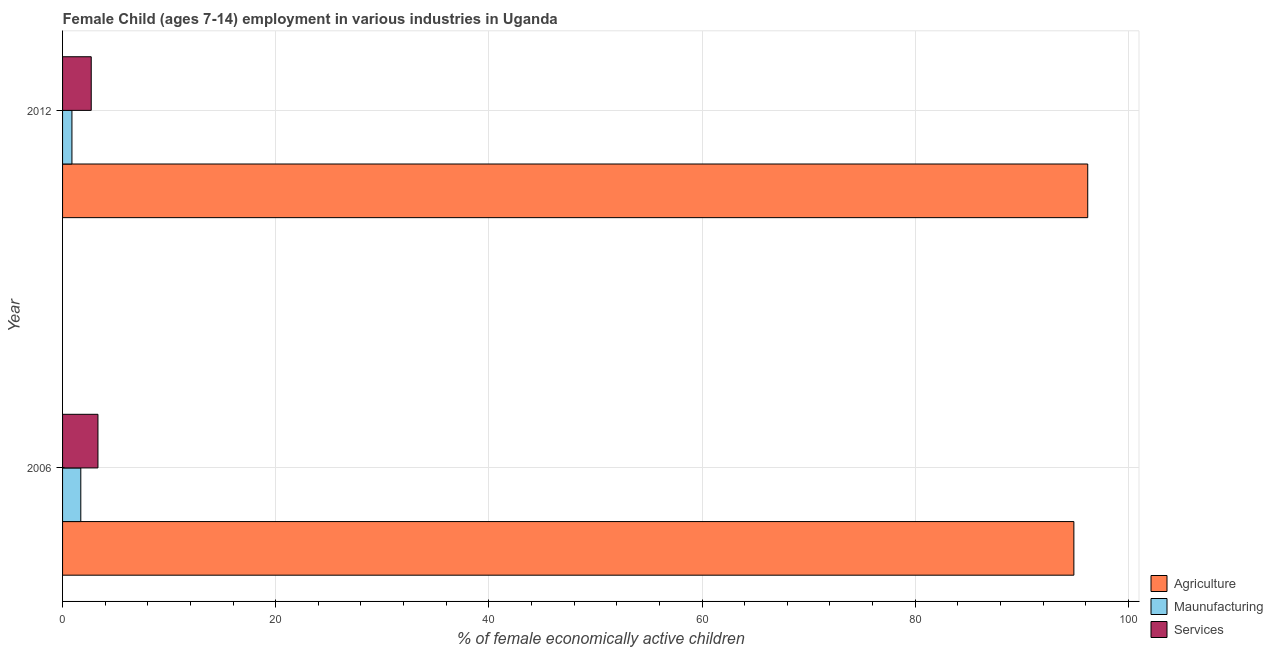How many groups of bars are there?
Your response must be concise. 2. Are the number of bars on each tick of the Y-axis equal?
Make the answer very short. Yes. What is the label of the 1st group of bars from the top?
Make the answer very short. 2012. In how many cases, is the number of bars for a given year not equal to the number of legend labels?
Your answer should be compact. 0. What is the percentage of economically active children in manufacturing in 2006?
Provide a short and direct response. 1.71. Across all years, what is the maximum percentage of economically active children in services?
Your answer should be compact. 3.32. Across all years, what is the minimum percentage of economically active children in services?
Your response must be concise. 2.69. In which year was the percentage of economically active children in agriculture maximum?
Your response must be concise. 2012. What is the total percentage of economically active children in agriculture in the graph?
Provide a short and direct response. 191.08. What is the difference between the percentage of economically active children in agriculture in 2006 and that in 2012?
Your answer should be very brief. -1.3. What is the difference between the percentage of economically active children in agriculture in 2006 and the percentage of economically active children in manufacturing in 2012?
Your answer should be compact. 94.01. What is the average percentage of economically active children in agriculture per year?
Offer a very short reply. 95.54. In the year 2012, what is the difference between the percentage of economically active children in services and percentage of economically active children in agriculture?
Ensure brevity in your answer.  -93.5. In how many years, is the percentage of economically active children in services greater than 44 %?
Provide a succinct answer. 0. Is the percentage of economically active children in services in 2006 less than that in 2012?
Offer a terse response. No. Is the difference between the percentage of economically active children in manufacturing in 2006 and 2012 greater than the difference between the percentage of economically active children in services in 2006 and 2012?
Make the answer very short. Yes. In how many years, is the percentage of economically active children in services greater than the average percentage of economically active children in services taken over all years?
Your response must be concise. 1. What does the 3rd bar from the top in 2012 represents?
Provide a succinct answer. Agriculture. What does the 1st bar from the bottom in 2012 represents?
Your response must be concise. Agriculture. Is it the case that in every year, the sum of the percentage of economically active children in agriculture and percentage of economically active children in manufacturing is greater than the percentage of economically active children in services?
Your answer should be very brief. Yes. Are all the bars in the graph horizontal?
Provide a short and direct response. Yes. How many legend labels are there?
Your answer should be compact. 3. What is the title of the graph?
Keep it short and to the point. Female Child (ages 7-14) employment in various industries in Uganda. What is the label or title of the X-axis?
Offer a very short reply. % of female economically active children. What is the % of female economically active children in Agriculture in 2006?
Ensure brevity in your answer.  94.89. What is the % of female economically active children in Maunufacturing in 2006?
Provide a short and direct response. 1.71. What is the % of female economically active children of Services in 2006?
Provide a short and direct response. 3.32. What is the % of female economically active children in Agriculture in 2012?
Your answer should be very brief. 96.19. What is the % of female economically active children of Maunufacturing in 2012?
Give a very brief answer. 0.88. What is the % of female economically active children in Services in 2012?
Provide a short and direct response. 2.69. Across all years, what is the maximum % of female economically active children of Agriculture?
Provide a short and direct response. 96.19. Across all years, what is the maximum % of female economically active children in Maunufacturing?
Offer a terse response. 1.71. Across all years, what is the maximum % of female economically active children in Services?
Offer a terse response. 3.32. Across all years, what is the minimum % of female economically active children in Agriculture?
Offer a very short reply. 94.89. Across all years, what is the minimum % of female economically active children of Maunufacturing?
Your answer should be very brief. 0.88. Across all years, what is the minimum % of female economically active children in Services?
Offer a very short reply. 2.69. What is the total % of female economically active children of Agriculture in the graph?
Your answer should be compact. 191.08. What is the total % of female economically active children of Maunufacturing in the graph?
Offer a very short reply. 2.59. What is the total % of female economically active children of Services in the graph?
Give a very brief answer. 6.01. What is the difference between the % of female economically active children in Maunufacturing in 2006 and that in 2012?
Your answer should be very brief. 0.83. What is the difference between the % of female economically active children of Services in 2006 and that in 2012?
Make the answer very short. 0.63. What is the difference between the % of female economically active children in Agriculture in 2006 and the % of female economically active children in Maunufacturing in 2012?
Give a very brief answer. 94.01. What is the difference between the % of female economically active children in Agriculture in 2006 and the % of female economically active children in Services in 2012?
Keep it short and to the point. 92.2. What is the difference between the % of female economically active children of Maunufacturing in 2006 and the % of female economically active children of Services in 2012?
Provide a succinct answer. -0.98. What is the average % of female economically active children in Agriculture per year?
Your answer should be very brief. 95.54. What is the average % of female economically active children in Maunufacturing per year?
Offer a terse response. 1.29. What is the average % of female economically active children of Services per year?
Make the answer very short. 3. In the year 2006, what is the difference between the % of female economically active children in Agriculture and % of female economically active children in Maunufacturing?
Your response must be concise. 93.18. In the year 2006, what is the difference between the % of female economically active children in Agriculture and % of female economically active children in Services?
Offer a terse response. 91.57. In the year 2006, what is the difference between the % of female economically active children of Maunufacturing and % of female economically active children of Services?
Your answer should be compact. -1.61. In the year 2012, what is the difference between the % of female economically active children in Agriculture and % of female economically active children in Maunufacturing?
Ensure brevity in your answer.  95.31. In the year 2012, what is the difference between the % of female economically active children of Agriculture and % of female economically active children of Services?
Keep it short and to the point. 93.5. In the year 2012, what is the difference between the % of female economically active children of Maunufacturing and % of female economically active children of Services?
Offer a very short reply. -1.81. What is the ratio of the % of female economically active children in Agriculture in 2006 to that in 2012?
Provide a succinct answer. 0.99. What is the ratio of the % of female economically active children of Maunufacturing in 2006 to that in 2012?
Offer a terse response. 1.94. What is the ratio of the % of female economically active children in Services in 2006 to that in 2012?
Provide a short and direct response. 1.23. What is the difference between the highest and the second highest % of female economically active children in Agriculture?
Your answer should be compact. 1.3. What is the difference between the highest and the second highest % of female economically active children in Maunufacturing?
Your answer should be compact. 0.83. What is the difference between the highest and the second highest % of female economically active children in Services?
Provide a short and direct response. 0.63. What is the difference between the highest and the lowest % of female economically active children in Agriculture?
Provide a succinct answer. 1.3. What is the difference between the highest and the lowest % of female economically active children of Maunufacturing?
Your answer should be compact. 0.83. What is the difference between the highest and the lowest % of female economically active children of Services?
Offer a terse response. 0.63. 